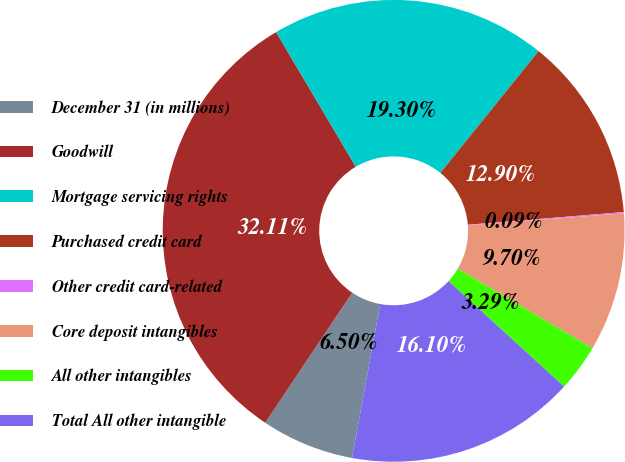<chart> <loc_0><loc_0><loc_500><loc_500><pie_chart><fcel>December 31 (in millions)<fcel>Goodwill<fcel>Mortgage servicing rights<fcel>Purchased credit card<fcel>Other credit card-related<fcel>Core deposit intangibles<fcel>All other intangibles<fcel>Total All other intangible<nl><fcel>6.5%<fcel>32.11%<fcel>19.3%<fcel>12.9%<fcel>0.09%<fcel>9.7%<fcel>3.29%<fcel>16.1%<nl></chart> 